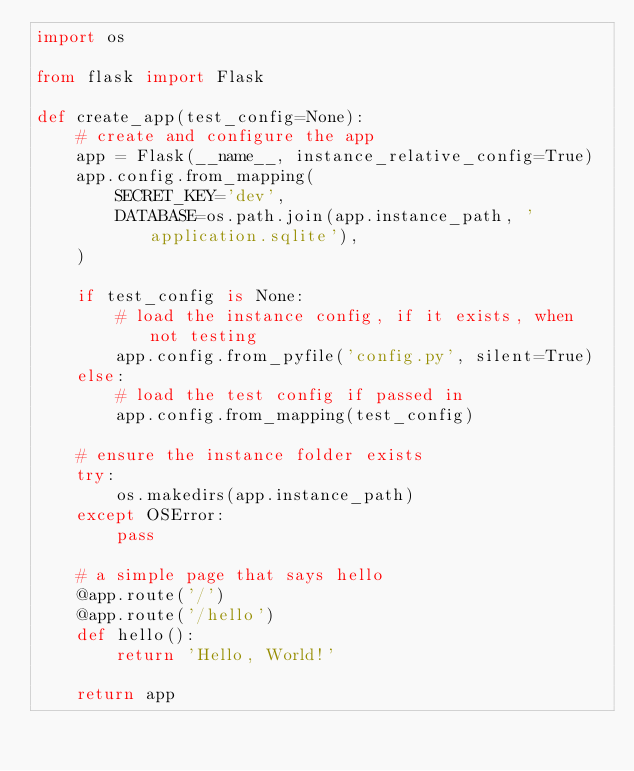<code> <loc_0><loc_0><loc_500><loc_500><_Python_>import os

from flask import Flask

def create_app(test_config=None):
    # create and configure the app
    app = Flask(__name__, instance_relative_config=True)
    app.config.from_mapping(
        SECRET_KEY='dev',
        DATABASE=os.path.join(app.instance_path, 'application.sqlite'),
    )

    if test_config is None:
        # load the instance config, if it exists, when not testing
        app.config.from_pyfile('config.py', silent=True)
    else:
        # load the test config if passed in
        app.config.from_mapping(test_config)

    # ensure the instance folder exists
    try:
        os.makedirs(app.instance_path)
    except OSError:
        pass

    # a simple page that says hello
    @app.route('/')
    @app.route('/hello')
    def hello():
        return 'Hello, World!'

    return app</code> 